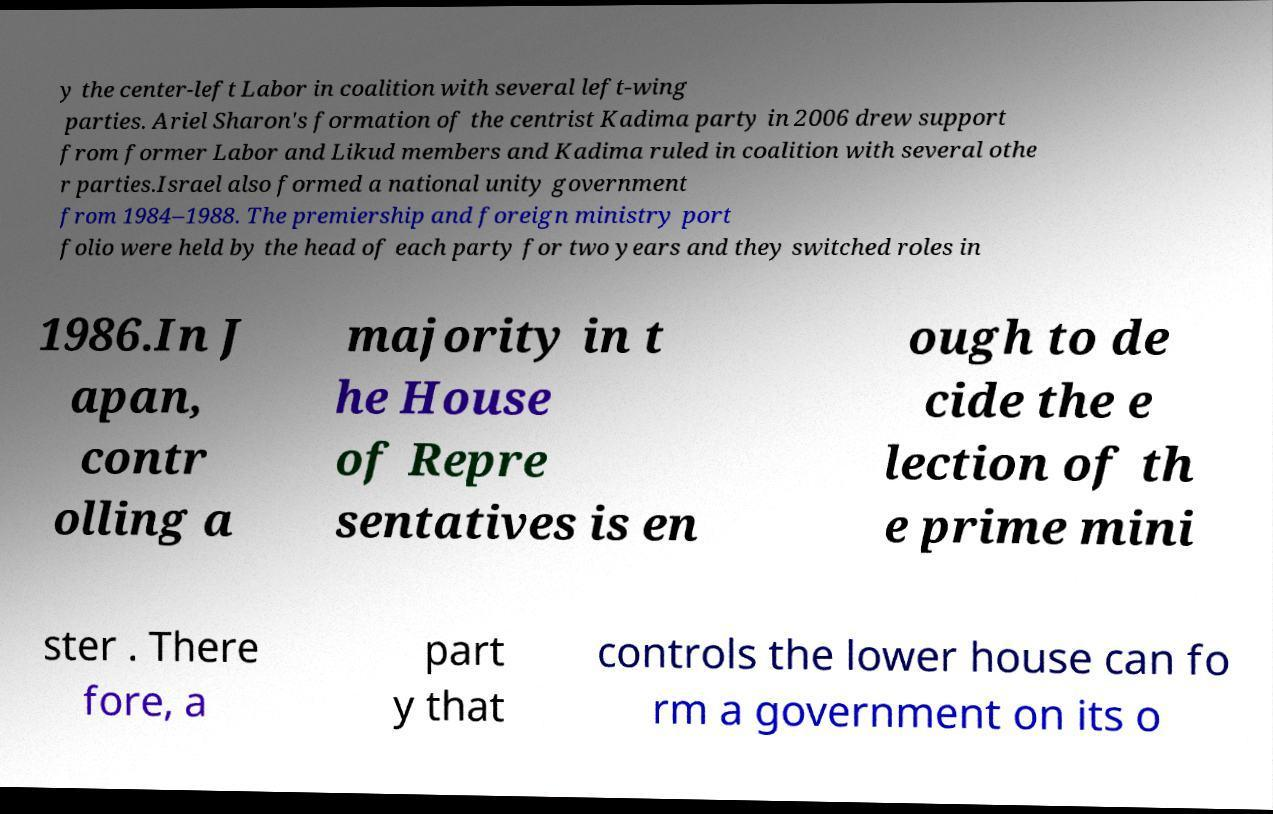Can you accurately transcribe the text from the provided image for me? y the center-left Labor in coalition with several left-wing parties. Ariel Sharon's formation of the centrist Kadima party in 2006 drew support from former Labor and Likud members and Kadima ruled in coalition with several othe r parties.Israel also formed a national unity government from 1984–1988. The premiership and foreign ministry port folio were held by the head of each party for two years and they switched roles in 1986.In J apan, contr olling a majority in t he House of Repre sentatives is en ough to de cide the e lection of th e prime mini ster . There fore, a part y that controls the lower house can fo rm a government on its o 